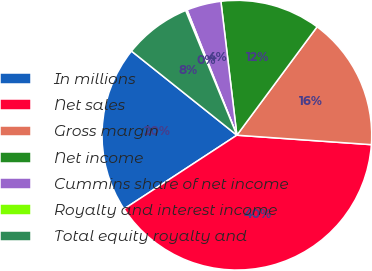Convert chart to OTSL. <chart><loc_0><loc_0><loc_500><loc_500><pie_chart><fcel>In millions<fcel>Net sales<fcel>Gross margin<fcel>Net income<fcel>Cummins share of net income<fcel>Royalty and interest income<fcel>Total equity royalty and<nl><fcel>19.93%<fcel>39.67%<fcel>15.98%<fcel>12.03%<fcel>4.13%<fcel>0.18%<fcel>8.08%<nl></chart> 